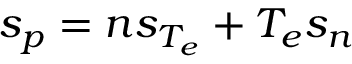Convert formula to latex. <formula><loc_0><loc_0><loc_500><loc_500>s _ { p } = n s _ { T _ { e } } + T _ { e } s _ { n }</formula> 